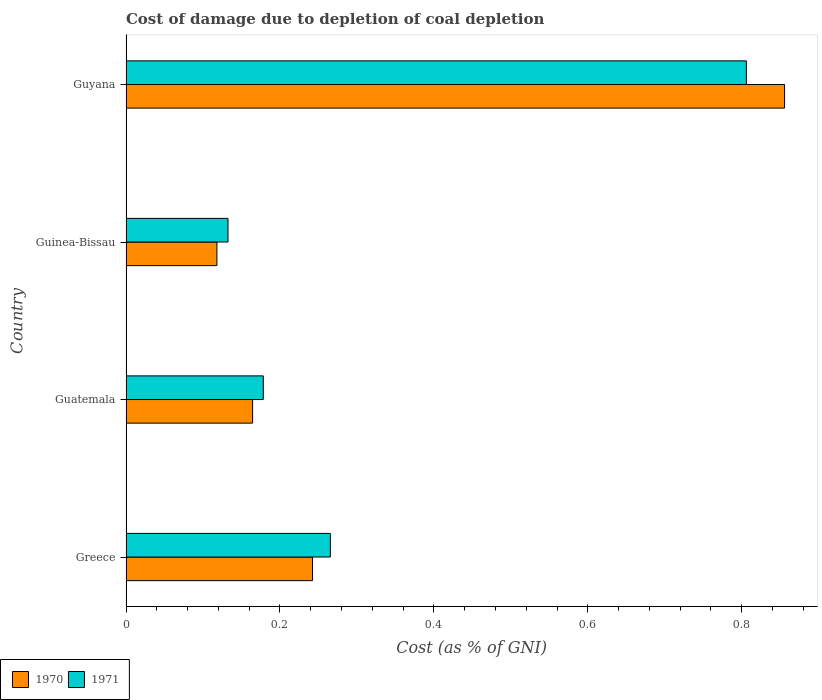How many different coloured bars are there?
Your answer should be very brief. 2. Are the number of bars per tick equal to the number of legend labels?
Your response must be concise. Yes. Are the number of bars on each tick of the Y-axis equal?
Your response must be concise. Yes. How many bars are there on the 1st tick from the top?
Make the answer very short. 2. How many bars are there on the 1st tick from the bottom?
Make the answer very short. 2. What is the label of the 1st group of bars from the top?
Your response must be concise. Guyana. What is the cost of damage caused due to coal depletion in 1971 in Guinea-Bissau?
Make the answer very short. 0.13. Across all countries, what is the maximum cost of damage caused due to coal depletion in 1971?
Make the answer very short. 0.81. Across all countries, what is the minimum cost of damage caused due to coal depletion in 1971?
Provide a succinct answer. 0.13. In which country was the cost of damage caused due to coal depletion in 1971 maximum?
Provide a succinct answer. Guyana. In which country was the cost of damage caused due to coal depletion in 1970 minimum?
Keep it short and to the point. Guinea-Bissau. What is the total cost of damage caused due to coal depletion in 1970 in the graph?
Make the answer very short. 1.38. What is the difference between the cost of damage caused due to coal depletion in 1970 in Greece and that in Guatemala?
Provide a short and direct response. 0.08. What is the difference between the cost of damage caused due to coal depletion in 1971 in Guyana and the cost of damage caused due to coal depletion in 1970 in Greece?
Provide a succinct answer. 0.56. What is the average cost of damage caused due to coal depletion in 1970 per country?
Your response must be concise. 0.35. What is the difference between the cost of damage caused due to coal depletion in 1971 and cost of damage caused due to coal depletion in 1970 in Greece?
Provide a short and direct response. 0.02. In how many countries, is the cost of damage caused due to coal depletion in 1971 greater than 0.52 %?
Your answer should be very brief. 1. What is the ratio of the cost of damage caused due to coal depletion in 1970 in Greece to that in Guinea-Bissau?
Offer a terse response. 2.05. Is the difference between the cost of damage caused due to coal depletion in 1971 in Guinea-Bissau and Guyana greater than the difference between the cost of damage caused due to coal depletion in 1970 in Guinea-Bissau and Guyana?
Offer a terse response. Yes. What is the difference between the highest and the second highest cost of damage caused due to coal depletion in 1971?
Your response must be concise. 0.54. What is the difference between the highest and the lowest cost of damage caused due to coal depletion in 1971?
Provide a succinct answer. 0.67. What does the 2nd bar from the top in Guinea-Bissau represents?
Ensure brevity in your answer.  1970. How many bars are there?
Provide a succinct answer. 8. How many countries are there in the graph?
Offer a terse response. 4. What is the difference between two consecutive major ticks on the X-axis?
Your answer should be very brief. 0.2. Are the values on the major ticks of X-axis written in scientific E-notation?
Make the answer very short. No. What is the title of the graph?
Your answer should be very brief. Cost of damage due to depletion of coal depletion. Does "2012" appear as one of the legend labels in the graph?
Your response must be concise. No. What is the label or title of the X-axis?
Offer a very short reply. Cost (as % of GNI). What is the Cost (as % of GNI) in 1970 in Greece?
Make the answer very short. 0.24. What is the Cost (as % of GNI) of 1971 in Greece?
Your answer should be very brief. 0.27. What is the Cost (as % of GNI) in 1970 in Guatemala?
Your answer should be very brief. 0.16. What is the Cost (as % of GNI) in 1971 in Guatemala?
Offer a terse response. 0.18. What is the Cost (as % of GNI) in 1970 in Guinea-Bissau?
Make the answer very short. 0.12. What is the Cost (as % of GNI) in 1971 in Guinea-Bissau?
Give a very brief answer. 0.13. What is the Cost (as % of GNI) of 1970 in Guyana?
Give a very brief answer. 0.86. What is the Cost (as % of GNI) of 1971 in Guyana?
Give a very brief answer. 0.81. Across all countries, what is the maximum Cost (as % of GNI) in 1970?
Offer a very short reply. 0.86. Across all countries, what is the maximum Cost (as % of GNI) in 1971?
Make the answer very short. 0.81. Across all countries, what is the minimum Cost (as % of GNI) in 1970?
Your answer should be compact. 0.12. Across all countries, what is the minimum Cost (as % of GNI) in 1971?
Give a very brief answer. 0.13. What is the total Cost (as % of GNI) in 1970 in the graph?
Your response must be concise. 1.38. What is the total Cost (as % of GNI) of 1971 in the graph?
Your response must be concise. 1.38. What is the difference between the Cost (as % of GNI) of 1970 in Greece and that in Guatemala?
Your answer should be very brief. 0.08. What is the difference between the Cost (as % of GNI) of 1971 in Greece and that in Guatemala?
Your response must be concise. 0.09. What is the difference between the Cost (as % of GNI) in 1970 in Greece and that in Guinea-Bissau?
Ensure brevity in your answer.  0.12. What is the difference between the Cost (as % of GNI) in 1971 in Greece and that in Guinea-Bissau?
Keep it short and to the point. 0.13. What is the difference between the Cost (as % of GNI) of 1970 in Greece and that in Guyana?
Make the answer very short. -0.61. What is the difference between the Cost (as % of GNI) in 1971 in Greece and that in Guyana?
Provide a succinct answer. -0.54. What is the difference between the Cost (as % of GNI) in 1970 in Guatemala and that in Guinea-Bissau?
Your answer should be very brief. 0.05. What is the difference between the Cost (as % of GNI) in 1971 in Guatemala and that in Guinea-Bissau?
Ensure brevity in your answer.  0.05. What is the difference between the Cost (as % of GNI) of 1970 in Guatemala and that in Guyana?
Keep it short and to the point. -0.69. What is the difference between the Cost (as % of GNI) in 1971 in Guatemala and that in Guyana?
Your answer should be very brief. -0.63. What is the difference between the Cost (as % of GNI) of 1970 in Guinea-Bissau and that in Guyana?
Your response must be concise. -0.74. What is the difference between the Cost (as % of GNI) in 1971 in Guinea-Bissau and that in Guyana?
Your answer should be very brief. -0.67. What is the difference between the Cost (as % of GNI) in 1970 in Greece and the Cost (as % of GNI) in 1971 in Guatemala?
Provide a short and direct response. 0.06. What is the difference between the Cost (as % of GNI) in 1970 in Greece and the Cost (as % of GNI) in 1971 in Guinea-Bissau?
Ensure brevity in your answer.  0.11. What is the difference between the Cost (as % of GNI) of 1970 in Greece and the Cost (as % of GNI) of 1971 in Guyana?
Your answer should be compact. -0.56. What is the difference between the Cost (as % of GNI) of 1970 in Guatemala and the Cost (as % of GNI) of 1971 in Guinea-Bissau?
Your answer should be very brief. 0.03. What is the difference between the Cost (as % of GNI) of 1970 in Guatemala and the Cost (as % of GNI) of 1971 in Guyana?
Your answer should be very brief. -0.64. What is the difference between the Cost (as % of GNI) in 1970 in Guinea-Bissau and the Cost (as % of GNI) in 1971 in Guyana?
Make the answer very short. -0.69. What is the average Cost (as % of GNI) in 1970 per country?
Offer a very short reply. 0.35. What is the average Cost (as % of GNI) in 1971 per country?
Offer a very short reply. 0.35. What is the difference between the Cost (as % of GNI) in 1970 and Cost (as % of GNI) in 1971 in Greece?
Offer a very short reply. -0.02. What is the difference between the Cost (as % of GNI) of 1970 and Cost (as % of GNI) of 1971 in Guatemala?
Your response must be concise. -0.01. What is the difference between the Cost (as % of GNI) in 1970 and Cost (as % of GNI) in 1971 in Guinea-Bissau?
Keep it short and to the point. -0.01. What is the difference between the Cost (as % of GNI) of 1970 and Cost (as % of GNI) of 1971 in Guyana?
Make the answer very short. 0.05. What is the ratio of the Cost (as % of GNI) of 1970 in Greece to that in Guatemala?
Provide a succinct answer. 1.47. What is the ratio of the Cost (as % of GNI) of 1971 in Greece to that in Guatemala?
Your response must be concise. 1.49. What is the ratio of the Cost (as % of GNI) of 1970 in Greece to that in Guinea-Bissau?
Keep it short and to the point. 2.05. What is the ratio of the Cost (as % of GNI) in 1971 in Greece to that in Guinea-Bissau?
Offer a very short reply. 2. What is the ratio of the Cost (as % of GNI) in 1970 in Greece to that in Guyana?
Make the answer very short. 0.28. What is the ratio of the Cost (as % of GNI) of 1971 in Greece to that in Guyana?
Your answer should be very brief. 0.33. What is the ratio of the Cost (as % of GNI) of 1970 in Guatemala to that in Guinea-Bissau?
Offer a terse response. 1.39. What is the ratio of the Cost (as % of GNI) of 1971 in Guatemala to that in Guinea-Bissau?
Your response must be concise. 1.35. What is the ratio of the Cost (as % of GNI) in 1970 in Guatemala to that in Guyana?
Your response must be concise. 0.19. What is the ratio of the Cost (as % of GNI) in 1971 in Guatemala to that in Guyana?
Provide a succinct answer. 0.22. What is the ratio of the Cost (as % of GNI) of 1970 in Guinea-Bissau to that in Guyana?
Make the answer very short. 0.14. What is the ratio of the Cost (as % of GNI) of 1971 in Guinea-Bissau to that in Guyana?
Your response must be concise. 0.16. What is the difference between the highest and the second highest Cost (as % of GNI) of 1970?
Keep it short and to the point. 0.61. What is the difference between the highest and the second highest Cost (as % of GNI) of 1971?
Provide a short and direct response. 0.54. What is the difference between the highest and the lowest Cost (as % of GNI) of 1970?
Provide a succinct answer. 0.74. What is the difference between the highest and the lowest Cost (as % of GNI) of 1971?
Provide a short and direct response. 0.67. 